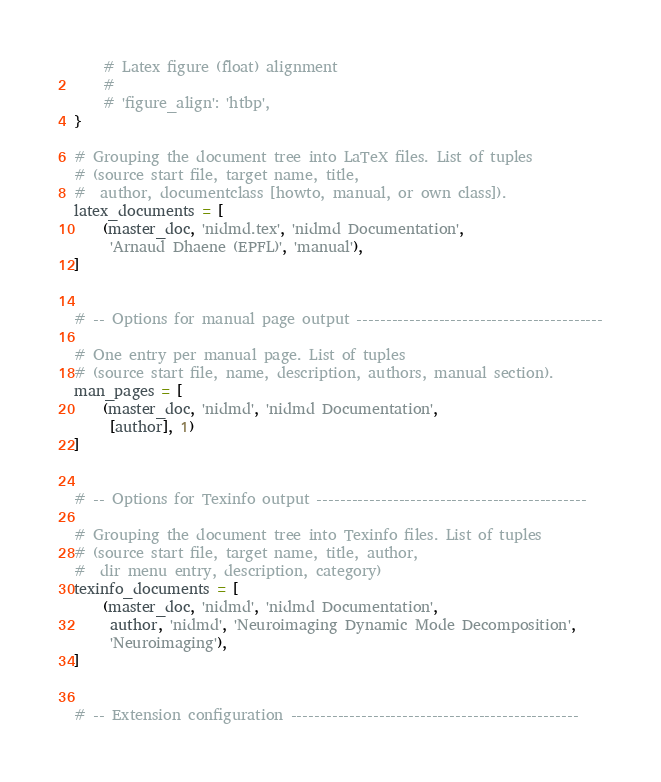Convert code to text. <code><loc_0><loc_0><loc_500><loc_500><_Python_>    # Latex figure (float) alignment
    #
    # 'figure_align': 'htbp',
}

# Grouping the document tree into LaTeX files. List of tuples
# (source start file, target name, title,
#  author, documentclass [howto, manual, or own class]).
latex_documents = [
    (master_doc, 'nidmd.tex', 'nidmd Documentation',
     'Arnaud Dhaene (EPFL)', 'manual'),
]


# -- Options for manual page output ------------------------------------------

# One entry per manual page. List of tuples
# (source start file, name, description, authors, manual section).
man_pages = [
    (master_doc, 'nidmd', 'nidmd Documentation',
     [author], 1)
]


# -- Options for Texinfo output ----------------------------------------------

# Grouping the document tree into Texinfo files. List of tuples
# (source start file, target name, title, author,
#  dir menu entry, description, category)
texinfo_documents = [
    (master_doc, 'nidmd', 'nidmd Documentation',
     author, 'nidmd', 'Neuroimaging Dynamic Mode Decomposition',
     'Neuroimaging'),
]


# -- Extension configuration -------------------------------------------------
</code> 